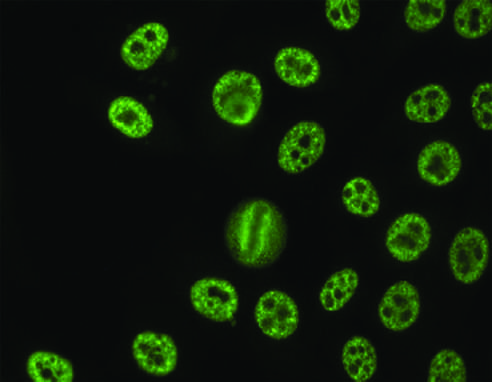what is seen with antibodies against various nuclear antigens, including sm and rnps?
Answer the question using a single word or phrase. A speckled pattern 